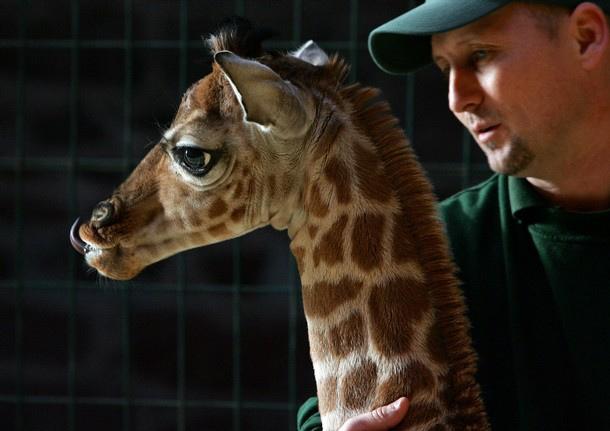Is this a toy giraffe?
Keep it brief. No. In which direction are the animals looking?
Answer briefly. Left. What color is the man's shirt?
Be succinct. Green. Is the man wearing glasses?
Write a very short answer. No. 